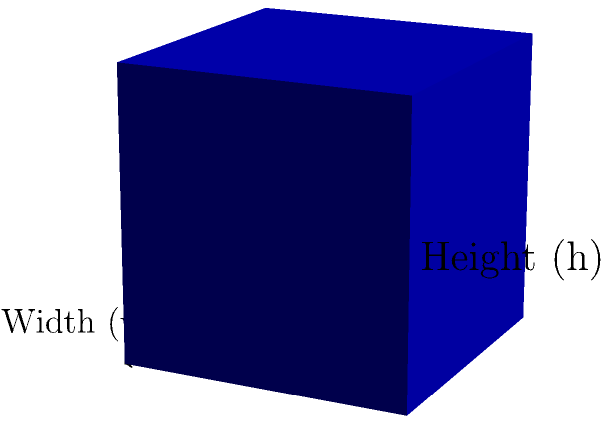Remember those old storage boxes we used in the lab? Let's say we have a rectangular prism-shaped box with a length of 8 inches, width of 6 inches, and height of 4 inches. How many cubic inches of chemicals could we safely store in this box? To find the volume of a rectangular prism, we need to multiply its length, width, and height. This is similar to how we calculate the volume of chemical solutions in the lab.

Let's break it down step-by-step:

1. Identify the dimensions:
   - Length (l) = 8 inches
   - Width (w) = 6 inches
   - Height (h) = 4 inches

2. Apply the formula for the volume of a rectangular prism:
   $$ V = l \times w \times h $$

3. Substitute the values:
   $$ V = 8 \text{ inches} \times 6 \text{ inches} \times 4 \text{ inches} $$

4. Multiply the numbers:
   $$ V = 192 \text{ cubic inches} $$

So, the volume of the box is 192 cubic inches. This means we could safely store up to 192 cubic inches of chemicals in this box, assuming it's properly sealed and suitable for chemical storage.
Answer: 192 cubic inches 